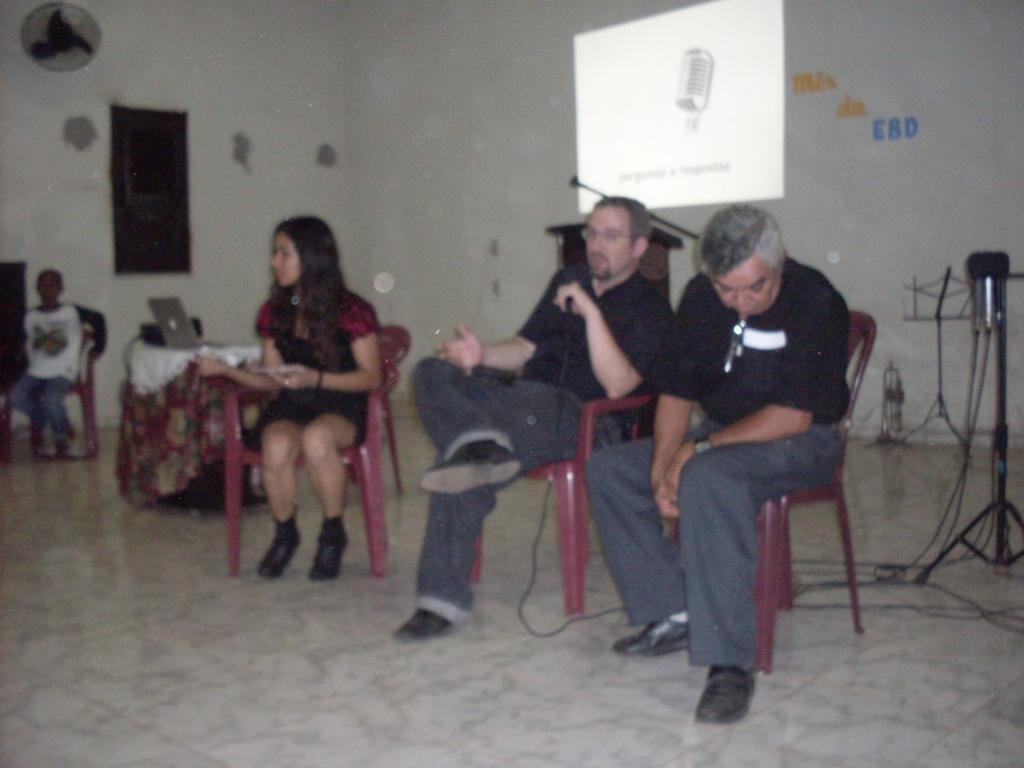Describe this image in one or two sentences. In this picture I can see four persons sitting on the chairs. There is a laptop on the table. I can see a podium, mike, musical book stand, fan, board attached to the wall and some other objects, and in the background there is a screen on the wall. 